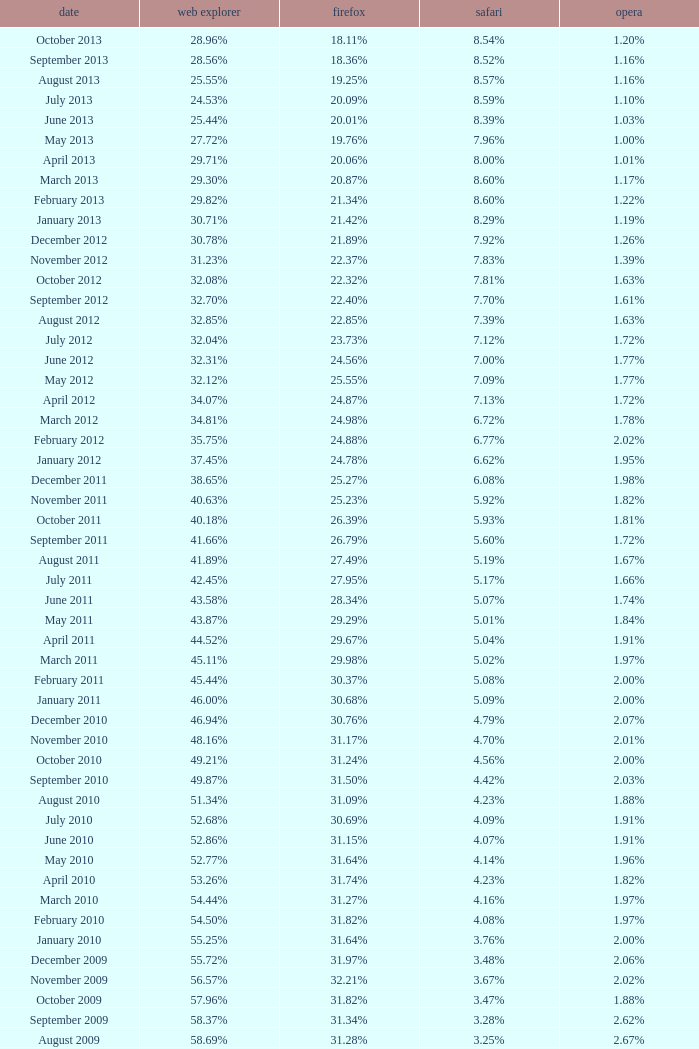Could you help me parse every detail presented in this table? {'header': ['date', 'web explorer', 'firefox', 'safari', 'opera'], 'rows': [['October 2013', '28.96%', '18.11%', '8.54%', '1.20%'], ['September 2013', '28.56%', '18.36%', '8.52%', '1.16%'], ['August 2013', '25.55%', '19.25%', '8.57%', '1.16%'], ['July 2013', '24.53%', '20.09%', '8.59%', '1.10%'], ['June 2013', '25.44%', '20.01%', '8.39%', '1.03%'], ['May 2013', '27.72%', '19.76%', '7.96%', '1.00%'], ['April 2013', '29.71%', '20.06%', '8.00%', '1.01%'], ['March 2013', '29.30%', '20.87%', '8.60%', '1.17%'], ['February 2013', '29.82%', '21.34%', '8.60%', '1.22%'], ['January 2013', '30.71%', '21.42%', '8.29%', '1.19%'], ['December 2012', '30.78%', '21.89%', '7.92%', '1.26%'], ['November 2012', '31.23%', '22.37%', '7.83%', '1.39%'], ['October 2012', '32.08%', '22.32%', '7.81%', '1.63%'], ['September 2012', '32.70%', '22.40%', '7.70%', '1.61%'], ['August 2012', '32.85%', '22.85%', '7.39%', '1.63%'], ['July 2012', '32.04%', '23.73%', '7.12%', '1.72%'], ['June 2012', '32.31%', '24.56%', '7.00%', '1.77%'], ['May 2012', '32.12%', '25.55%', '7.09%', '1.77%'], ['April 2012', '34.07%', '24.87%', '7.13%', '1.72%'], ['March 2012', '34.81%', '24.98%', '6.72%', '1.78%'], ['February 2012', '35.75%', '24.88%', '6.77%', '2.02%'], ['January 2012', '37.45%', '24.78%', '6.62%', '1.95%'], ['December 2011', '38.65%', '25.27%', '6.08%', '1.98%'], ['November 2011', '40.63%', '25.23%', '5.92%', '1.82%'], ['October 2011', '40.18%', '26.39%', '5.93%', '1.81%'], ['September 2011', '41.66%', '26.79%', '5.60%', '1.72%'], ['August 2011', '41.89%', '27.49%', '5.19%', '1.67%'], ['July 2011', '42.45%', '27.95%', '5.17%', '1.66%'], ['June 2011', '43.58%', '28.34%', '5.07%', '1.74%'], ['May 2011', '43.87%', '29.29%', '5.01%', '1.84%'], ['April 2011', '44.52%', '29.67%', '5.04%', '1.91%'], ['March 2011', '45.11%', '29.98%', '5.02%', '1.97%'], ['February 2011', '45.44%', '30.37%', '5.08%', '2.00%'], ['January 2011', '46.00%', '30.68%', '5.09%', '2.00%'], ['December 2010', '46.94%', '30.76%', '4.79%', '2.07%'], ['November 2010', '48.16%', '31.17%', '4.70%', '2.01%'], ['October 2010', '49.21%', '31.24%', '4.56%', '2.00%'], ['September 2010', '49.87%', '31.50%', '4.42%', '2.03%'], ['August 2010', '51.34%', '31.09%', '4.23%', '1.88%'], ['July 2010', '52.68%', '30.69%', '4.09%', '1.91%'], ['June 2010', '52.86%', '31.15%', '4.07%', '1.91%'], ['May 2010', '52.77%', '31.64%', '4.14%', '1.96%'], ['April 2010', '53.26%', '31.74%', '4.23%', '1.82%'], ['March 2010', '54.44%', '31.27%', '4.16%', '1.97%'], ['February 2010', '54.50%', '31.82%', '4.08%', '1.97%'], ['January 2010', '55.25%', '31.64%', '3.76%', '2.00%'], ['December 2009', '55.72%', '31.97%', '3.48%', '2.06%'], ['November 2009', '56.57%', '32.21%', '3.67%', '2.02%'], ['October 2009', '57.96%', '31.82%', '3.47%', '1.88%'], ['September 2009', '58.37%', '31.34%', '3.28%', '2.62%'], ['August 2009', '58.69%', '31.28%', '3.25%', '2.67%'], ['July 2009', '60.11%', '30.50%', '3.02%', '2.64%'], ['June 2009', '59.49%', '30.26%', '2.91%', '3.46%'], ['May 2009', '62.09%', '28.75%', '2.65%', '3.23%'], ['April 2009', '61.88%', '29.67%', '2.75%', '2.96%'], ['March 2009', '62.52%', '29.40%', '2.73%', '2.94%'], ['February 2009', '64.43%', '27.85%', '2.59%', '2.95%'], ['January 2009', '65.41%', '27.03%', '2.57%', '2.92%'], ['December 2008', '67.84%', '25.23%', '2.41%', '2.83%'], ['November 2008', '68.14%', '25.27%', '2.49%', '3.01%'], ['October 2008', '67.68%', '25.54%', '2.91%', '2.69%'], ['September2008', '67.16%', '25.77%', '3.00%', '2.86%'], ['August 2008', '68.91%', '26.08%', '2.99%', '1.83%'], ['July 2008', '68.57%', '26.14%', '3.30%', '1.78%']]} What percentage of browsers were using Internet Explorer in April 2009? 61.88%. 